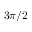Convert formula to latex. <formula><loc_0><loc_0><loc_500><loc_500>3 \pi / 2</formula> 